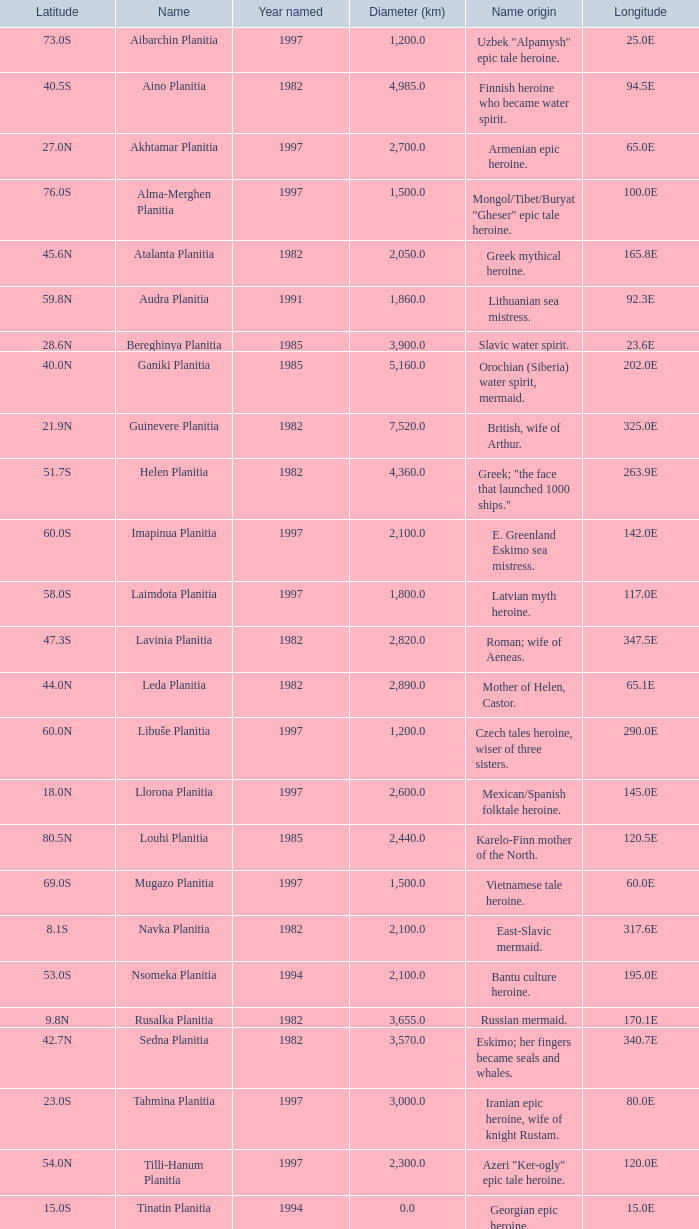What is the diameter (km) of the feature of latitude 23.0s 3000.0. Parse the table in full. {'header': ['Latitude', 'Name', 'Year named', 'Diameter (km)', 'Name origin', 'Longitude'], 'rows': [['73.0S', 'Aibarchin Planitia', '1997', '1,200.0', 'Uzbek "Alpamysh" epic tale heroine.', '25.0E'], ['40.5S', 'Aino Planitia', '1982', '4,985.0', 'Finnish heroine who became water spirit.', '94.5E'], ['27.0N', 'Akhtamar Planitia', '1997', '2,700.0', 'Armenian epic heroine.', '65.0E'], ['76.0S', 'Alma-Merghen Planitia', '1997', '1,500.0', 'Mongol/Tibet/Buryat "Gheser" epic tale heroine.', '100.0E'], ['45.6N', 'Atalanta Planitia', '1982', '2,050.0', 'Greek mythical heroine.', '165.8E'], ['59.8N', 'Audra Planitia', '1991', '1,860.0', 'Lithuanian sea mistress.', '92.3E'], ['28.6N', 'Bereghinya Planitia', '1985', '3,900.0', 'Slavic water spirit.', '23.6E'], ['40.0N', 'Ganiki Planitia', '1985', '5,160.0', 'Orochian (Siberia) water spirit, mermaid.', '202.0E'], ['21.9N', 'Guinevere Planitia', '1982', '7,520.0', 'British, wife of Arthur.', '325.0E'], ['51.7S', 'Helen Planitia', '1982', '4,360.0', 'Greek; "the face that launched 1000 ships."', '263.9E'], ['60.0S', 'Imapinua Planitia', '1997', '2,100.0', 'E. Greenland Eskimo sea mistress.', '142.0E'], ['58.0S', 'Laimdota Planitia', '1997', '1,800.0', 'Latvian myth heroine.', '117.0E'], ['47.3S', 'Lavinia Planitia', '1982', '2,820.0', 'Roman; wife of Aeneas.', '347.5E'], ['44.0N', 'Leda Planitia', '1982', '2,890.0', 'Mother of Helen, Castor.', '65.1E'], ['60.0N', 'Libuše Planitia', '1997', '1,200.0', 'Czech tales heroine, wiser of three sisters.', '290.0E'], ['18.0N', 'Llorona Planitia', '1997', '2,600.0', 'Mexican/Spanish folktale heroine.', '145.0E'], ['80.5N', 'Louhi Planitia', '1985', '2,440.0', 'Karelo-Finn mother of the North.', '120.5E'], ['69.0S', 'Mugazo Planitia', '1997', '1,500.0', 'Vietnamese tale heroine.', '60.0E'], ['8.1S', 'Navka Planitia', '1982', '2,100.0', 'East-Slavic mermaid.', '317.6E'], ['53.0S', 'Nsomeka Planitia', '1994', '2,100.0', 'Bantu culture heroine.', '195.0E'], ['9.8N', 'Rusalka Planitia', '1982', '3,655.0', 'Russian mermaid.', '170.1E'], ['42.7N', 'Sedna Planitia', '1982', '3,570.0', 'Eskimo; her fingers became seals and whales.', '340.7E'], ['23.0S', 'Tahmina Planitia', '1997', '3,000.0', 'Iranian epic heroine, wife of knight Rustam.', '80.0E'], ['54.0N', 'Tilli-Hanum Planitia', '1997', '2,300.0', 'Azeri "Ker-ogly" epic tale heroine.', '120.0E'], ['15.0S', 'Tinatin Planitia', '1994', '0.0', 'Georgian epic heroine.', '15.0E'], ['13.0N', 'Undine Planitia', '1997', '2,800.0', 'Lithuanian water nymph, mermaid.', '303.0E'], ['45.4N', 'Vellamo Planitia', '1985', '2,155.0', 'Karelo-Finn mermaid.', '149.1E']]} 